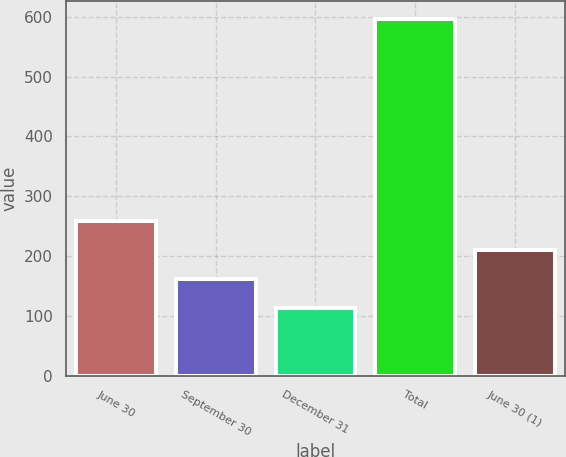Convert chart to OTSL. <chart><loc_0><loc_0><loc_500><loc_500><bar_chart><fcel>June 30<fcel>September 30<fcel>December 31<fcel>Total<fcel>June 30 (1)<nl><fcel>257.9<fcel>161.3<fcel>113<fcel>596<fcel>209.6<nl></chart> 